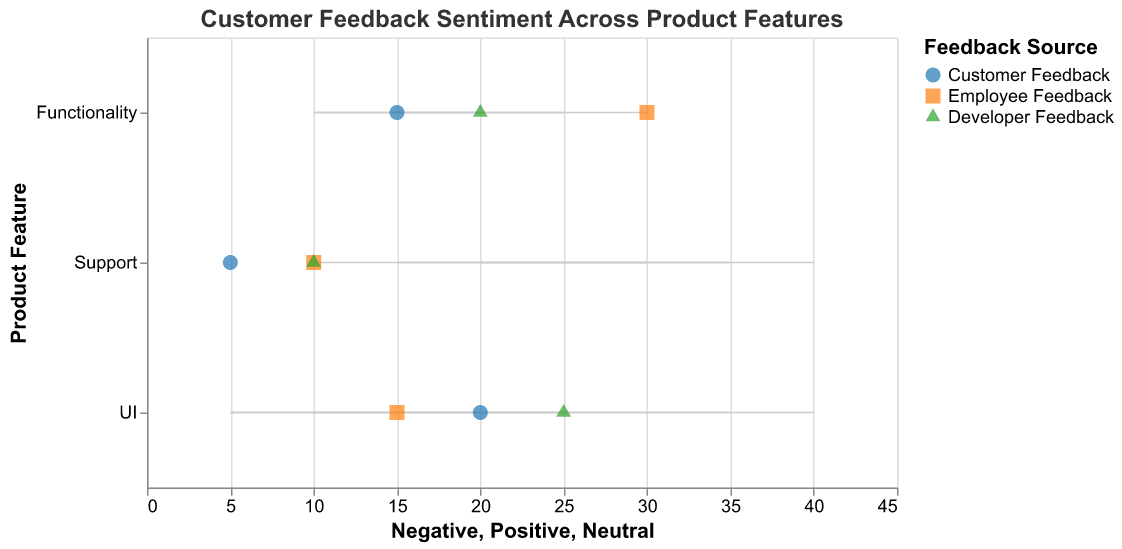Which product feature received the most positive feedback from customers? Looking at the plot and identifying the largest value in the "Positive" section for "Customer Feedback," which corresponds to "Support" with a value of 40.
Answer: Support Which category has the highest neutral feedback for UI? By looking at the neutral feedback values for the "UI" feature, we identify the highest value in the "Neutral" section across all categories, which shows "Developer Feedback" with a value of 25.
Answer: Developer Feedback What's the difference in positive feedback between customer feedback and employee feedback for functionality? The positive feedback for functionality in customer feedback is 30 and in employee feedback is 25. The difference can be calculated as 30 - 25 = 5.
Answer: 5 Between employee feedback and developer feedback for support, which has more negative feedback? By comparing the negative feedback values for support, employee feedback has a value of 10 and developer feedback has 20. Hence, developer feedback is higher.
Answer: Developer Feedback Which category received the highest positive feedback for the functionality feature? Looking at the "Functionality" section, the highest value in the "Positive" column is found in customer feedback with a value of 30.
Answer: Customer Feedback How does the neutral feedback for UI compare between customers and employees? The neutral feedback for UI from customers is 20, while from employees it is 15. Customers have more neutral feedback than employees.
Answer: Customers have more Is there any feature where developer feedback has more negative comments than customer feedback? By comparing negative feedback across all features, for "UI," "Functionality," and "Support," developer feedback has negative values of 10, 10, and 20 respectively, while customer feedback has 5, 10, and 15 respectively. "Support" is the feature where developer feedback is higher (20 vs 15).
Answer: Support Among all feedback categories for UI, which has the smallest range between positive and negative feedback? Compute the range by subtracting the negative feedback from the positive feedback for each category: Customer (35-5=30), Employee (40-5=35), and Developer (25-10=15). The smallest range is for Developer Feedback.
Answer: Developer Feedback Which product feature has the lowest negative feedback from employees? By examining the negative feedback values for employees across all features, the lowest value is for "UI" with a value of 5.
Answer: UI 